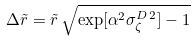<formula> <loc_0><loc_0><loc_500><loc_500>\Delta { \tilde { r } } = { \tilde { r } } \, \sqrt { \exp [ \alpha ^ { 2 } \sigma _ { \zeta } ^ { D \, 2 } ] - 1 }</formula> 